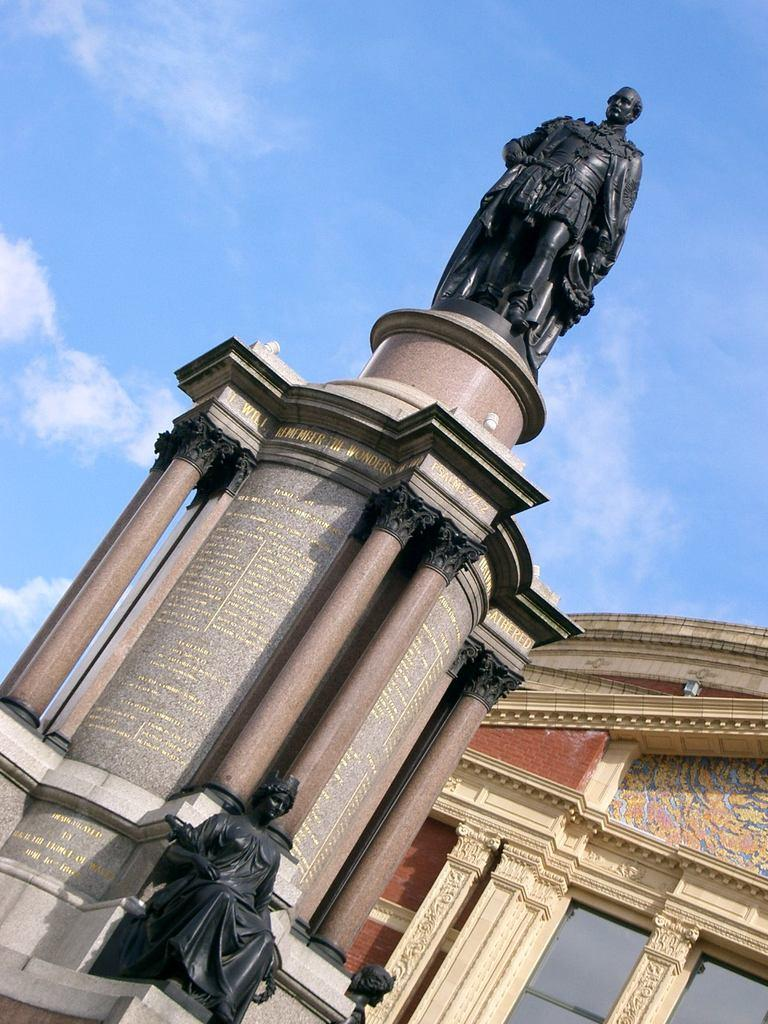What color is the sky in the image? The sky is blue in the image. What type of artistic objects can be seen in the image? There are sculptures in the image. What type of building is present in the image? There is a building with glass windows in the image. What brand of toothpaste is being advertised on the sculptures in the image? There is no toothpaste or advertisement present in the image; it features sculptures and a building with glass windows. How does the loss of the writer affect the sculptures in the image? There is no mention of a writer or any loss in the image; it only features sculptures and a building with glass windows. 